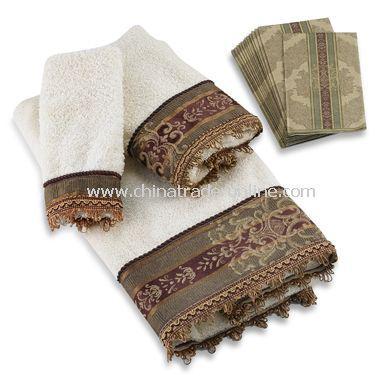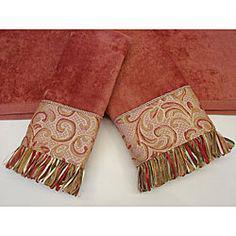The first image is the image on the left, the second image is the image on the right. Assess this claim about the two images: "One image shows a pair of yarn-fringed towels displayed on a solid towel.". Correct or not? Answer yes or no. Yes. 